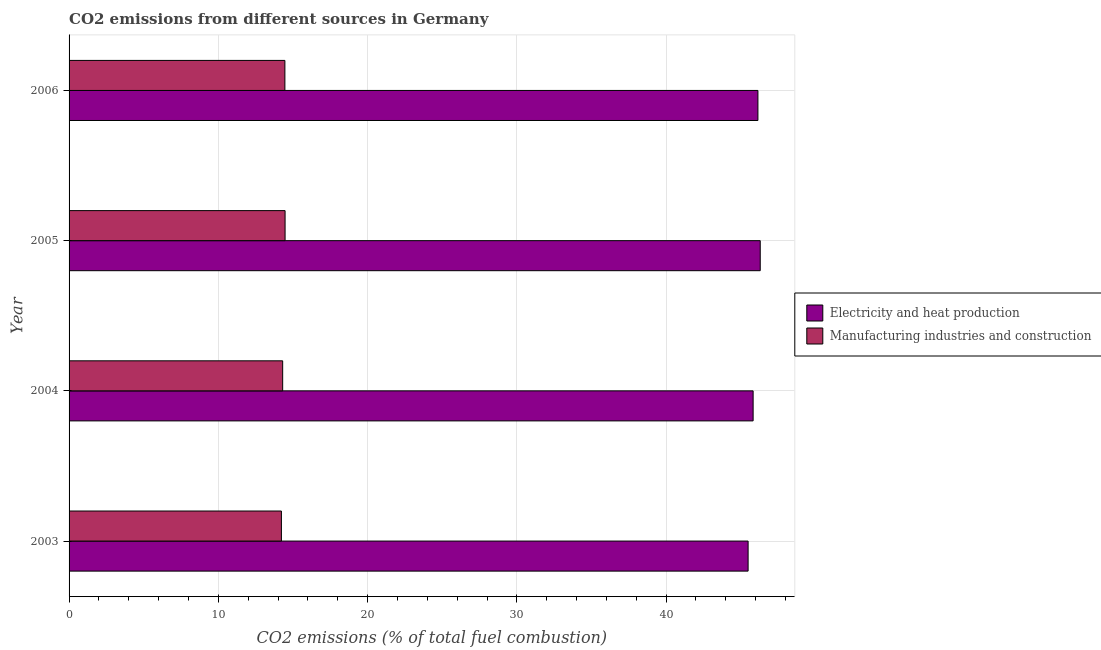How many groups of bars are there?
Ensure brevity in your answer.  4. Are the number of bars per tick equal to the number of legend labels?
Your answer should be very brief. Yes. Are the number of bars on each tick of the Y-axis equal?
Your response must be concise. Yes. What is the label of the 4th group of bars from the top?
Your answer should be very brief. 2003. What is the co2 emissions due to manufacturing industries in 2006?
Keep it short and to the point. 14.46. Across all years, what is the maximum co2 emissions due to manufacturing industries?
Your response must be concise. 14.47. Across all years, what is the minimum co2 emissions due to electricity and heat production?
Provide a succinct answer. 45.49. In which year was the co2 emissions due to electricity and heat production maximum?
Your answer should be very brief. 2005. What is the total co2 emissions due to manufacturing industries in the graph?
Give a very brief answer. 57.47. What is the difference between the co2 emissions due to electricity and heat production in 2004 and that in 2006?
Keep it short and to the point. -0.32. What is the difference between the co2 emissions due to electricity and heat production in 2005 and the co2 emissions due to manufacturing industries in 2003?
Your answer should be very brief. 32.08. What is the average co2 emissions due to electricity and heat production per year?
Your answer should be very brief. 45.94. In the year 2004, what is the difference between the co2 emissions due to manufacturing industries and co2 emissions due to electricity and heat production?
Offer a terse response. -31.52. Is the difference between the co2 emissions due to manufacturing industries in 2003 and 2005 greater than the difference between the co2 emissions due to electricity and heat production in 2003 and 2005?
Make the answer very short. Yes. What is the difference between the highest and the second highest co2 emissions due to manufacturing industries?
Provide a short and direct response. 0.01. What is the difference between the highest and the lowest co2 emissions due to manufacturing industries?
Offer a very short reply. 0.25. In how many years, is the co2 emissions due to electricity and heat production greater than the average co2 emissions due to electricity and heat production taken over all years?
Keep it short and to the point. 2. Is the sum of the co2 emissions due to manufacturing industries in 2003 and 2006 greater than the maximum co2 emissions due to electricity and heat production across all years?
Offer a terse response. No. What does the 1st bar from the top in 2006 represents?
Your answer should be compact. Manufacturing industries and construction. What does the 1st bar from the bottom in 2004 represents?
Your answer should be compact. Electricity and heat production. Are all the bars in the graph horizontal?
Keep it short and to the point. Yes. What is the title of the graph?
Provide a short and direct response. CO2 emissions from different sources in Germany. Does "Primary school" appear as one of the legend labels in the graph?
Give a very brief answer. No. What is the label or title of the X-axis?
Your answer should be very brief. CO2 emissions (% of total fuel combustion). What is the label or title of the Y-axis?
Give a very brief answer. Year. What is the CO2 emissions (% of total fuel combustion) of Electricity and heat production in 2003?
Your response must be concise. 45.49. What is the CO2 emissions (% of total fuel combustion) of Manufacturing industries and construction in 2003?
Give a very brief answer. 14.23. What is the CO2 emissions (% of total fuel combustion) in Electricity and heat production in 2004?
Offer a very short reply. 45.83. What is the CO2 emissions (% of total fuel combustion) of Manufacturing industries and construction in 2004?
Your answer should be compact. 14.31. What is the CO2 emissions (% of total fuel combustion) in Electricity and heat production in 2005?
Your response must be concise. 46.3. What is the CO2 emissions (% of total fuel combustion) in Manufacturing industries and construction in 2005?
Your answer should be very brief. 14.47. What is the CO2 emissions (% of total fuel combustion) of Electricity and heat production in 2006?
Your answer should be compact. 46.15. What is the CO2 emissions (% of total fuel combustion) in Manufacturing industries and construction in 2006?
Your response must be concise. 14.46. Across all years, what is the maximum CO2 emissions (% of total fuel combustion) in Electricity and heat production?
Offer a very short reply. 46.3. Across all years, what is the maximum CO2 emissions (% of total fuel combustion) in Manufacturing industries and construction?
Offer a terse response. 14.47. Across all years, what is the minimum CO2 emissions (% of total fuel combustion) of Electricity and heat production?
Provide a succinct answer. 45.49. Across all years, what is the minimum CO2 emissions (% of total fuel combustion) in Manufacturing industries and construction?
Ensure brevity in your answer.  14.23. What is the total CO2 emissions (% of total fuel combustion) of Electricity and heat production in the graph?
Offer a very short reply. 183.78. What is the total CO2 emissions (% of total fuel combustion) of Manufacturing industries and construction in the graph?
Ensure brevity in your answer.  57.47. What is the difference between the CO2 emissions (% of total fuel combustion) of Electricity and heat production in 2003 and that in 2004?
Give a very brief answer. -0.34. What is the difference between the CO2 emissions (% of total fuel combustion) of Manufacturing industries and construction in 2003 and that in 2004?
Make the answer very short. -0.08. What is the difference between the CO2 emissions (% of total fuel combustion) in Electricity and heat production in 2003 and that in 2005?
Your answer should be compact. -0.81. What is the difference between the CO2 emissions (% of total fuel combustion) in Manufacturing industries and construction in 2003 and that in 2005?
Give a very brief answer. -0.25. What is the difference between the CO2 emissions (% of total fuel combustion) in Electricity and heat production in 2003 and that in 2006?
Offer a terse response. -0.66. What is the difference between the CO2 emissions (% of total fuel combustion) in Manufacturing industries and construction in 2003 and that in 2006?
Keep it short and to the point. -0.23. What is the difference between the CO2 emissions (% of total fuel combustion) in Electricity and heat production in 2004 and that in 2005?
Give a very brief answer. -0.48. What is the difference between the CO2 emissions (% of total fuel combustion) of Manufacturing industries and construction in 2004 and that in 2005?
Ensure brevity in your answer.  -0.16. What is the difference between the CO2 emissions (% of total fuel combustion) of Electricity and heat production in 2004 and that in 2006?
Provide a short and direct response. -0.32. What is the difference between the CO2 emissions (% of total fuel combustion) of Manufacturing industries and construction in 2004 and that in 2006?
Offer a terse response. -0.15. What is the difference between the CO2 emissions (% of total fuel combustion) in Electricity and heat production in 2005 and that in 2006?
Provide a succinct answer. 0.15. What is the difference between the CO2 emissions (% of total fuel combustion) of Manufacturing industries and construction in 2005 and that in 2006?
Your answer should be very brief. 0.01. What is the difference between the CO2 emissions (% of total fuel combustion) in Electricity and heat production in 2003 and the CO2 emissions (% of total fuel combustion) in Manufacturing industries and construction in 2004?
Ensure brevity in your answer.  31.18. What is the difference between the CO2 emissions (% of total fuel combustion) in Electricity and heat production in 2003 and the CO2 emissions (% of total fuel combustion) in Manufacturing industries and construction in 2005?
Offer a terse response. 31.02. What is the difference between the CO2 emissions (% of total fuel combustion) of Electricity and heat production in 2003 and the CO2 emissions (% of total fuel combustion) of Manufacturing industries and construction in 2006?
Provide a succinct answer. 31.03. What is the difference between the CO2 emissions (% of total fuel combustion) of Electricity and heat production in 2004 and the CO2 emissions (% of total fuel combustion) of Manufacturing industries and construction in 2005?
Make the answer very short. 31.36. What is the difference between the CO2 emissions (% of total fuel combustion) in Electricity and heat production in 2004 and the CO2 emissions (% of total fuel combustion) in Manufacturing industries and construction in 2006?
Your answer should be very brief. 31.37. What is the difference between the CO2 emissions (% of total fuel combustion) in Electricity and heat production in 2005 and the CO2 emissions (% of total fuel combustion) in Manufacturing industries and construction in 2006?
Provide a short and direct response. 31.85. What is the average CO2 emissions (% of total fuel combustion) of Electricity and heat production per year?
Keep it short and to the point. 45.94. What is the average CO2 emissions (% of total fuel combustion) in Manufacturing industries and construction per year?
Your answer should be compact. 14.37. In the year 2003, what is the difference between the CO2 emissions (% of total fuel combustion) of Electricity and heat production and CO2 emissions (% of total fuel combustion) of Manufacturing industries and construction?
Your response must be concise. 31.27. In the year 2004, what is the difference between the CO2 emissions (% of total fuel combustion) of Electricity and heat production and CO2 emissions (% of total fuel combustion) of Manufacturing industries and construction?
Your answer should be compact. 31.52. In the year 2005, what is the difference between the CO2 emissions (% of total fuel combustion) in Electricity and heat production and CO2 emissions (% of total fuel combustion) in Manufacturing industries and construction?
Offer a terse response. 31.83. In the year 2006, what is the difference between the CO2 emissions (% of total fuel combustion) of Electricity and heat production and CO2 emissions (% of total fuel combustion) of Manufacturing industries and construction?
Offer a very short reply. 31.69. What is the ratio of the CO2 emissions (% of total fuel combustion) of Electricity and heat production in 2003 to that in 2004?
Make the answer very short. 0.99. What is the ratio of the CO2 emissions (% of total fuel combustion) in Electricity and heat production in 2003 to that in 2005?
Your answer should be very brief. 0.98. What is the ratio of the CO2 emissions (% of total fuel combustion) in Manufacturing industries and construction in 2003 to that in 2005?
Your response must be concise. 0.98. What is the ratio of the CO2 emissions (% of total fuel combustion) of Electricity and heat production in 2003 to that in 2006?
Your answer should be very brief. 0.99. What is the ratio of the CO2 emissions (% of total fuel combustion) in Manufacturing industries and construction in 2003 to that in 2006?
Offer a very short reply. 0.98. What is the ratio of the CO2 emissions (% of total fuel combustion) of Manufacturing industries and construction in 2004 to that in 2006?
Offer a terse response. 0.99. What is the ratio of the CO2 emissions (% of total fuel combustion) of Manufacturing industries and construction in 2005 to that in 2006?
Provide a short and direct response. 1. What is the difference between the highest and the second highest CO2 emissions (% of total fuel combustion) of Electricity and heat production?
Ensure brevity in your answer.  0.15. What is the difference between the highest and the second highest CO2 emissions (% of total fuel combustion) in Manufacturing industries and construction?
Your answer should be very brief. 0.01. What is the difference between the highest and the lowest CO2 emissions (% of total fuel combustion) of Electricity and heat production?
Your response must be concise. 0.81. What is the difference between the highest and the lowest CO2 emissions (% of total fuel combustion) of Manufacturing industries and construction?
Provide a short and direct response. 0.25. 